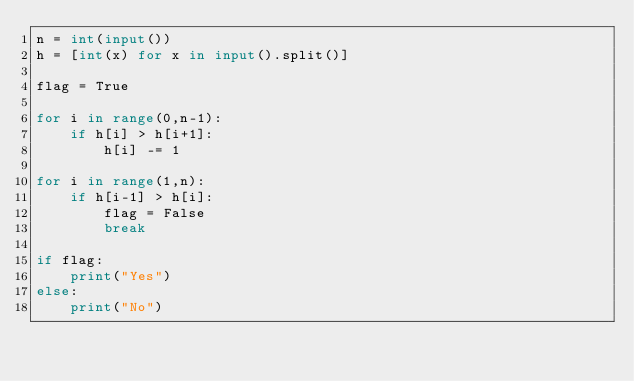<code> <loc_0><loc_0><loc_500><loc_500><_Python_>n = int(input())
h = [int(x) for x in input().split()]

flag = True

for i in range(0,n-1):
    if h[i] > h[i+1]:
        h[i] -= 1

for i in range(1,n):
    if h[i-1] > h[i]:
        flag = False
        break

if flag:
    print("Yes")
else:
    print("No")
</code> 